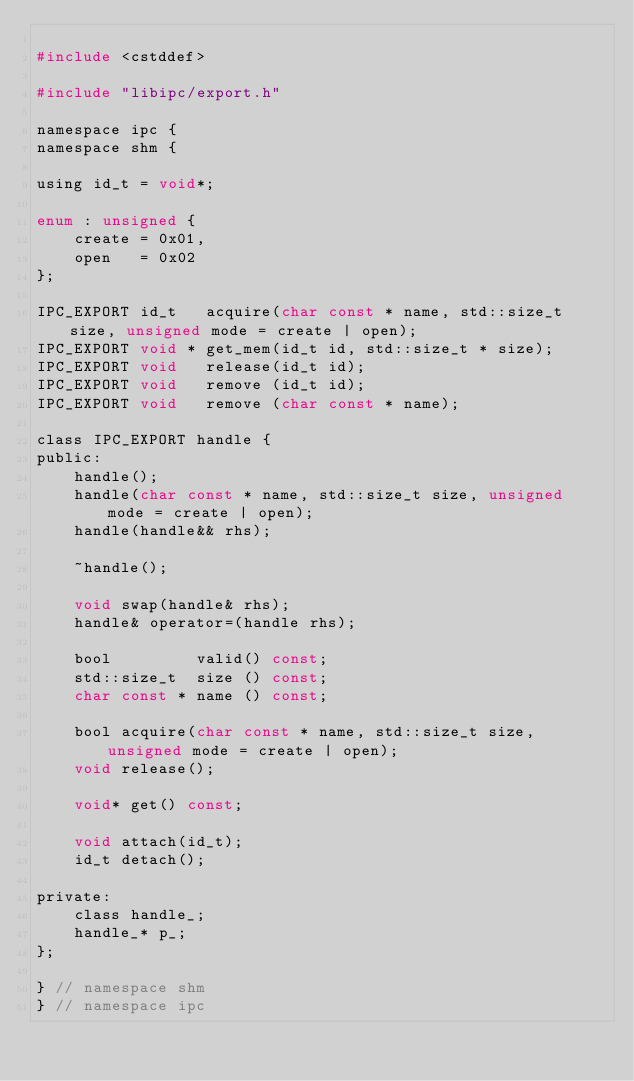<code> <loc_0><loc_0><loc_500><loc_500><_C_>
#include <cstddef>

#include "libipc/export.h"

namespace ipc {
namespace shm {

using id_t = void*;

enum : unsigned {
    create = 0x01,
    open   = 0x02
};

IPC_EXPORT id_t   acquire(char const * name, std::size_t size, unsigned mode = create | open);
IPC_EXPORT void * get_mem(id_t id, std::size_t * size);
IPC_EXPORT void   release(id_t id);
IPC_EXPORT void   remove (id_t id);
IPC_EXPORT void   remove (char const * name);

class IPC_EXPORT handle {
public:
    handle();
    handle(char const * name, std::size_t size, unsigned mode = create | open);
    handle(handle&& rhs);

    ~handle();

    void swap(handle& rhs);
    handle& operator=(handle rhs);

    bool         valid() const;
    std::size_t  size () const;
    char const * name () const;

    bool acquire(char const * name, std::size_t size, unsigned mode = create | open);
    void release();

    void* get() const;

    void attach(id_t);
    id_t detach();

private:
    class handle_;
    handle_* p_;
};

} // namespace shm
} // namespace ipc
</code> 